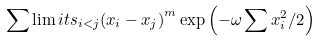<formula> <loc_0><loc_0><loc_500><loc_500>\sum \lim i t s _ { i < j } { \left ( { x _ { i } - x _ { j } } \right ) } ^ { m } \exp \left ( { - \omega \sum { x _ { i } ^ { 2 } / 2 } } \right )</formula> 